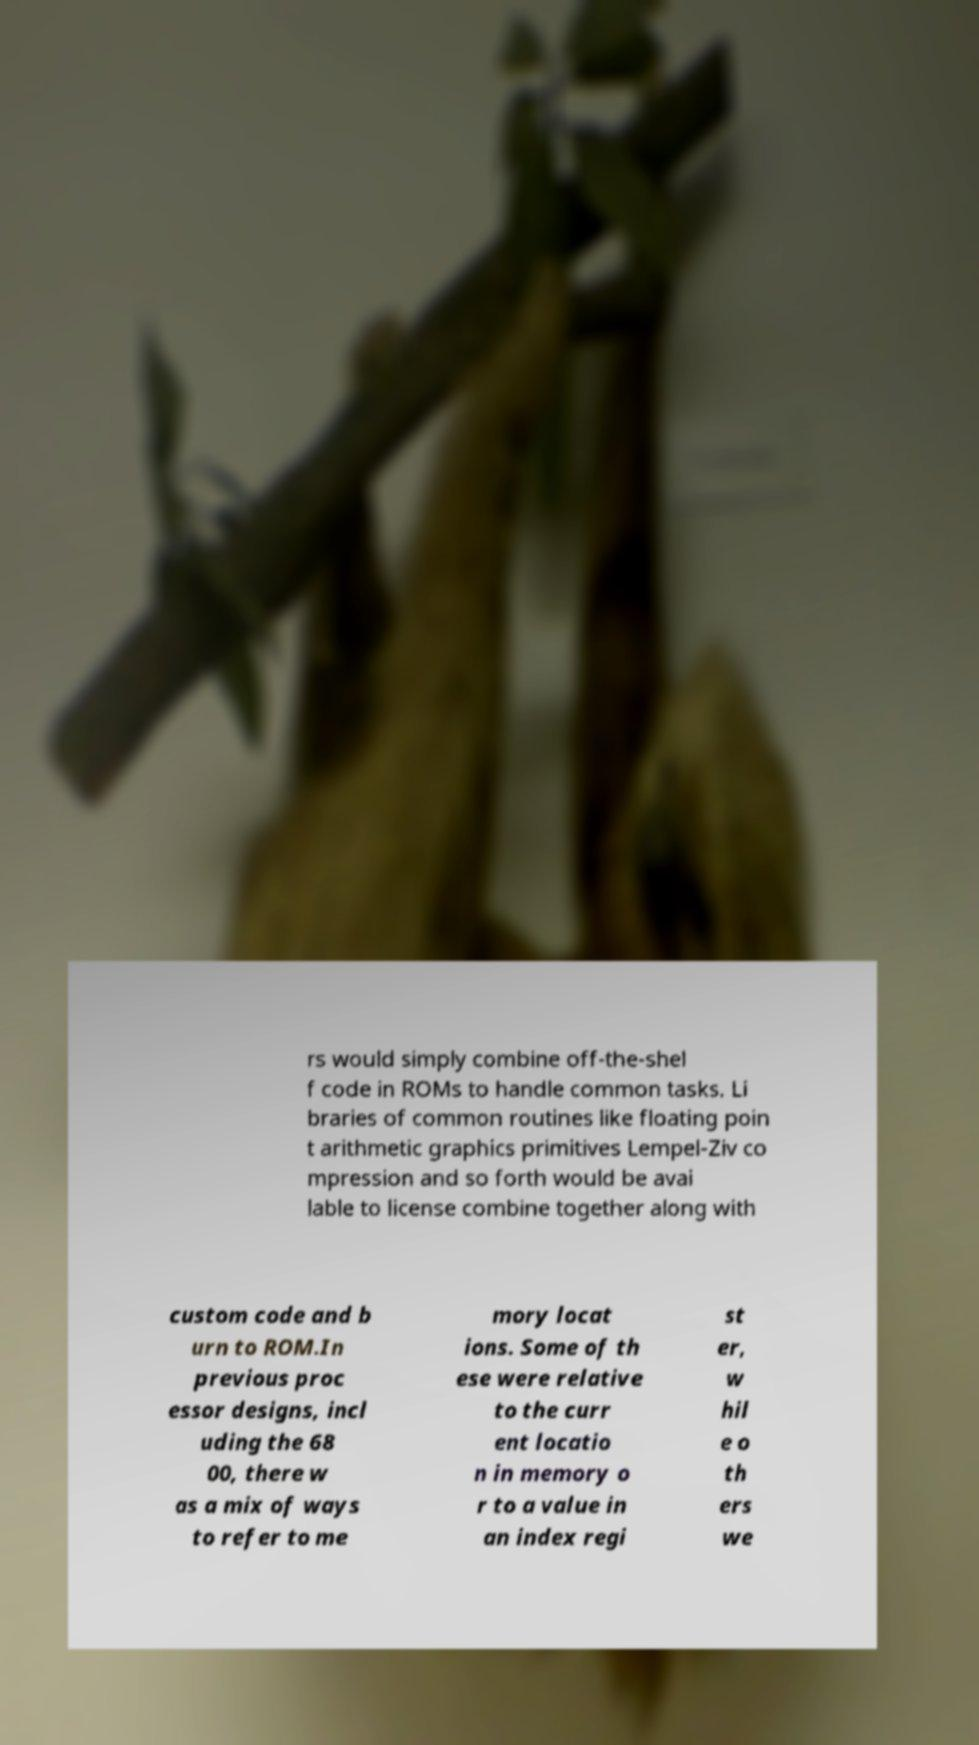What messages or text are displayed in this image? I need them in a readable, typed format. rs would simply combine off-the-shel f code in ROMs to handle common tasks. Li braries of common routines like floating poin t arithmetic graphics primitives Lempel-Ziv co mpression and so forth would be avai lable to license combine together along with custom code and b urn to ROM.In previous proc essor designs, incl uding the 68 00, there w as a mix of ways to refer to me mory locat ions. Some of th ese were relative to the curr ent locatio n in memory o r to a value in an index regi st er, w hil e o th ers we 